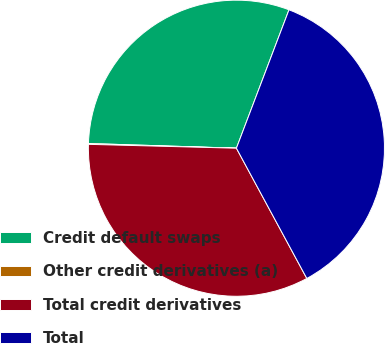Convert chart to OTSL. <chart><loc_0><loc_0><loc_500><loc_500><pie_chart><fcel>Credit default swaps<fcel>Other credit derivatives (a)<fcel>Total credit derivatives<fcel>Total<nl><fcel>30.27%<fcel>0.09%<fcel>33.3%<fcel>36.33%<nl></chart> 